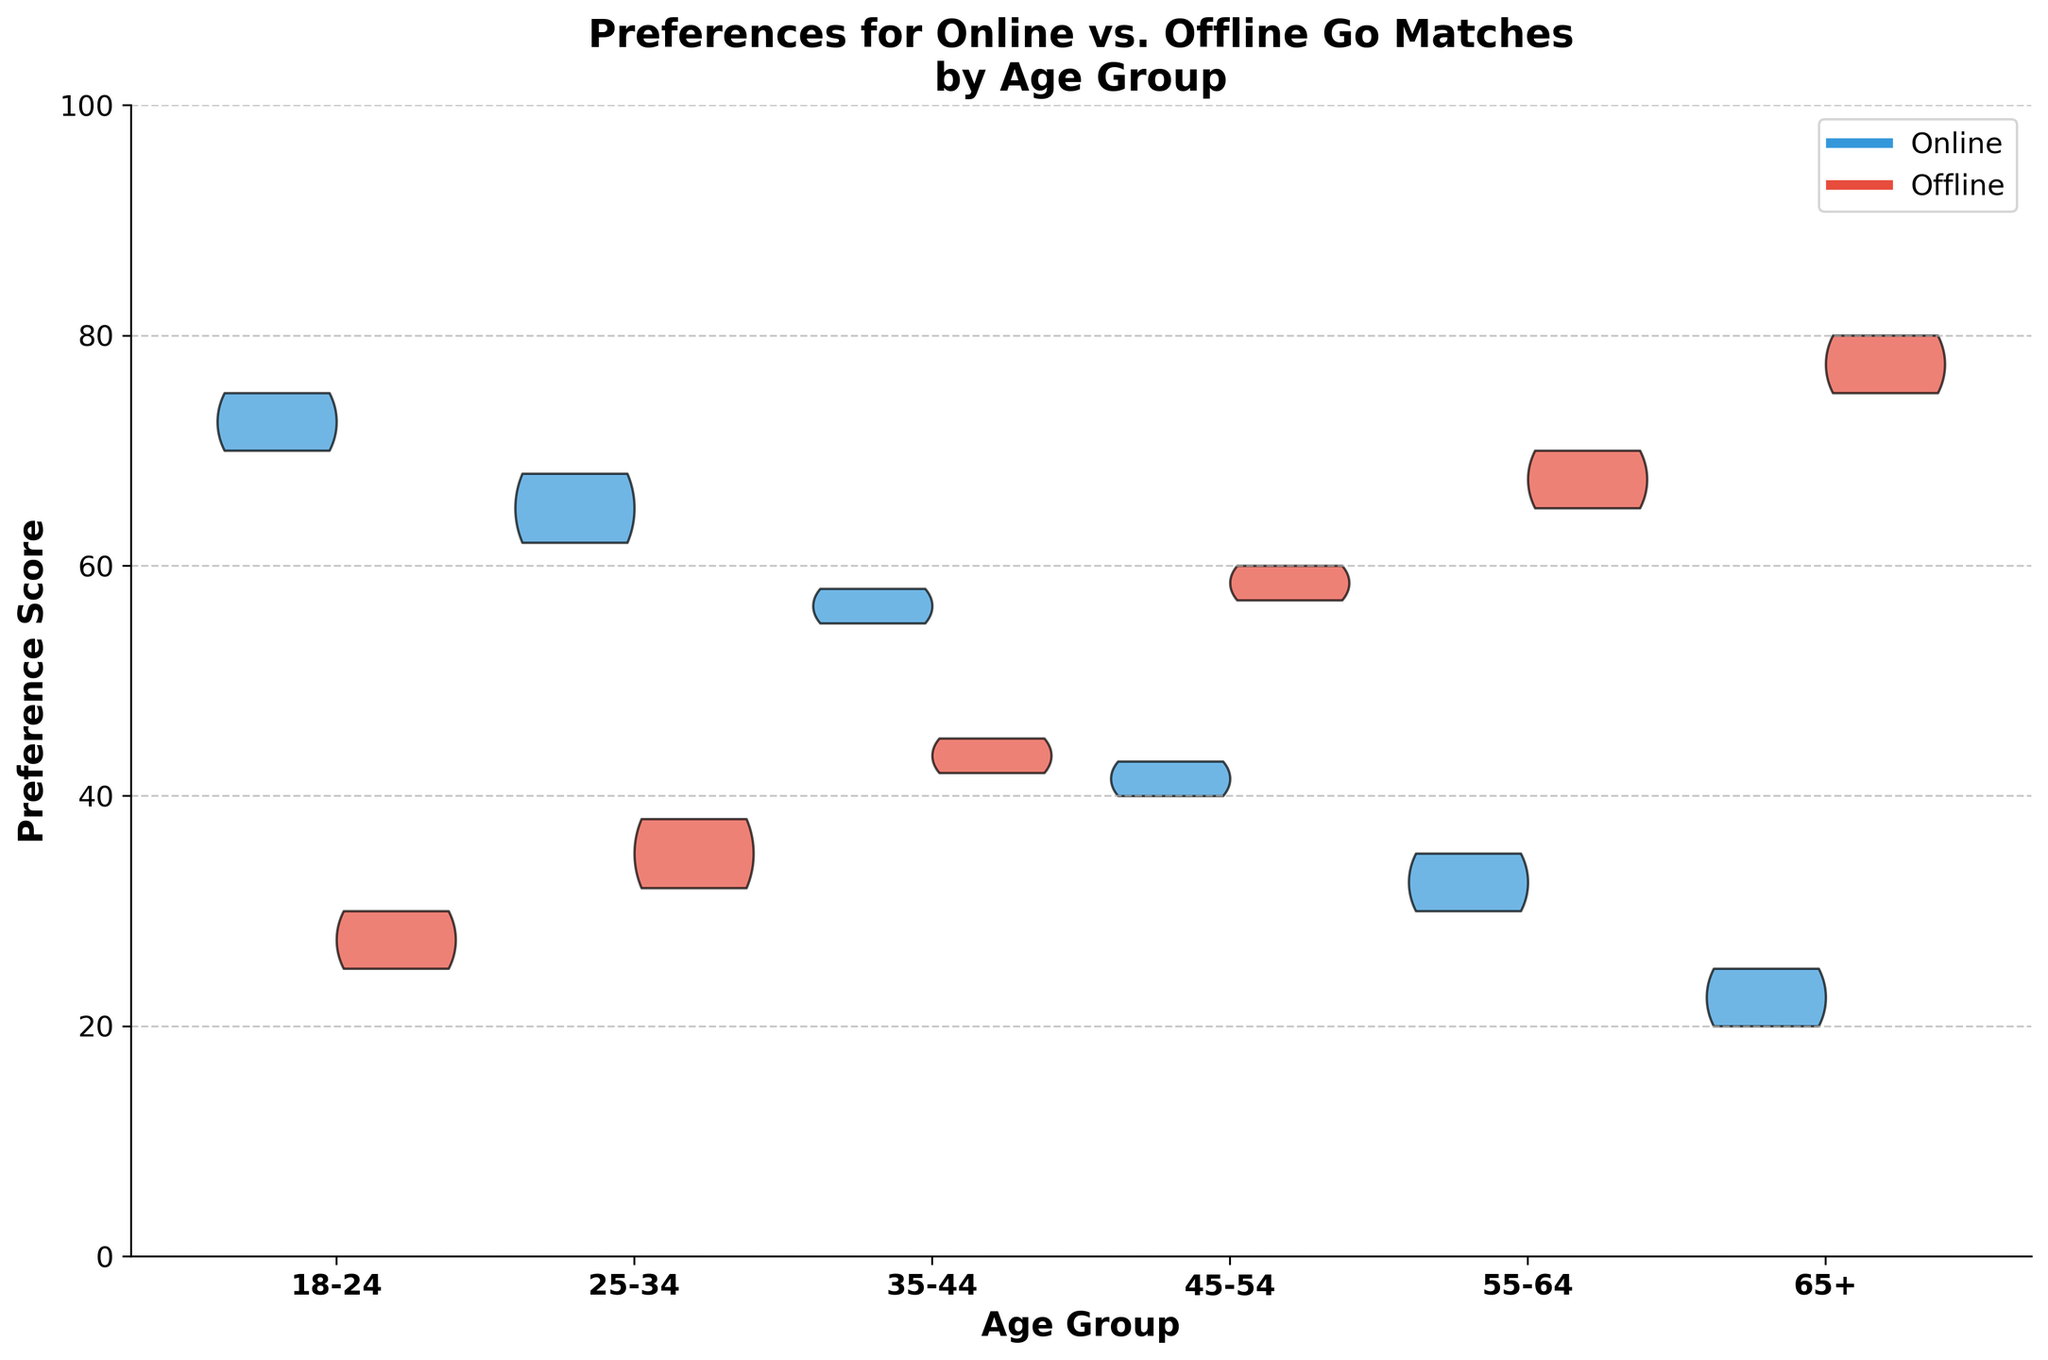what's the title of the plot? The title is typically found at the top of the plot and often summarizes what the plot is displaying. In this case, the title is "Preferences for Online vs. Offline Go Matches by Age Group".
Answer: Preferences for Online vs. Offline Go Matches by Age Group what are the x-axis labels in the plot? The x-axis labels represent the different categories being compared, which in this plot are the age groups.
Answer: 18-24, 25-34, 35-44, 45-54, 55-64, 65+ what are the colors used for online and offline matches? The colors used help differentiate between online and offline matches visually. In this plot, online matches are represented by a blue color, and offline matches are represented by a red color.
Answer: blue and red which age group prefers online matches the most? To determine this, we look at the age group with the highest preference score for online matches. The interest for online matches is highest among the 18-24 age group.
Answer: 18-24 how does the preference for offline matches change as age increases? By observing the shape of the violin plots for offline matches across different age groups, we can see that preference scores for offline matches generally increase as age increases, being the highest in the 65+ age group.
Answer: It increases which age group has the most similar preference scores for online and offline matches? This requires comparing the scores of each age group to identify the smallest difference between online and offline preferences. The 35-44 age group has relatively balanced scores between online and offline preferences.
Answer: 35-44 what is the offline preference score range for the 45-54 age group? Looking at the width of the violin plot for offline matches within the 45-54 age group, we need to determine the spread of the scores. The offline preference scores range from approximately 55 to 60 for this group.
Answer: 55-60 do any age groups show a higher preference for offline matches than the 65+ age group? Examining the heights of the offline match violins, we see that the 65+ age group has the highest preference score for offline matches, indicating no other group exceeds it.
Answer: No what trend can be observed when comparing online match preferences across age groups? Analyzing the distribution of online match preferences from younger to older age groups, we observe a decreasing trend in preference for online matches as age increases.
Answer: Decreasing trend which age group shows the widest range in preference scores for online matches? We need to compare the width and spread of the violin plots for online matches. The 18-24 age group shows the widest range in preference scores for online matches, indicating higher variability.
Answer: 18-24 